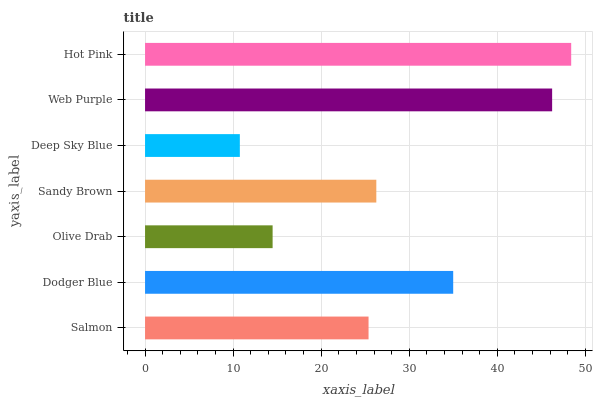Is Deep Sky Blue the minimum?
Answer yes or no. Yes. Is Hot Pink the maximum?
Answer yes or no. Yes. Is Dodger Blue the minimum?
Answer yes or no. No. Is Dodger Blue the maximum?
Answer yes or no. No. Is Dodger Blue greater than Salmon?
Answer yes or no. Yes. Is Salmon less than Dodger Blue?
Answer yes or no. Yes. Is Salmon greater than Dodger Blue?
Answer yes or no. No. Is Dodger Blue less than Salmon?
Answer yes or no. No. Is Sandy Brown the high median?
Answer yes or no. Yes. Is Sandy Brown the low median?
Answer yes or no. Yes. Is Deep Sky Blue the high median?
Answer yes or no. No. Is Olive Drab the low median?
Answer yes or no. No. 